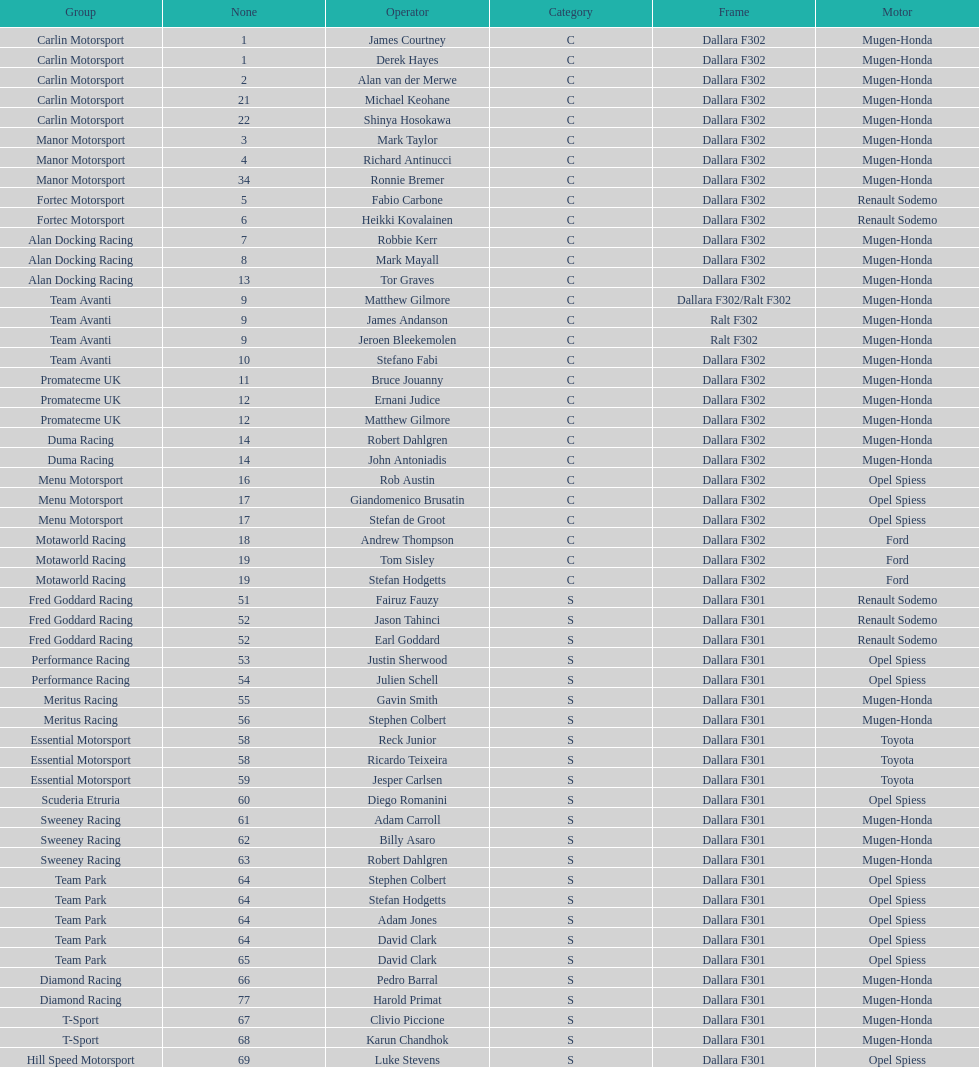What is the total number of class c (championship) teams? 21. 